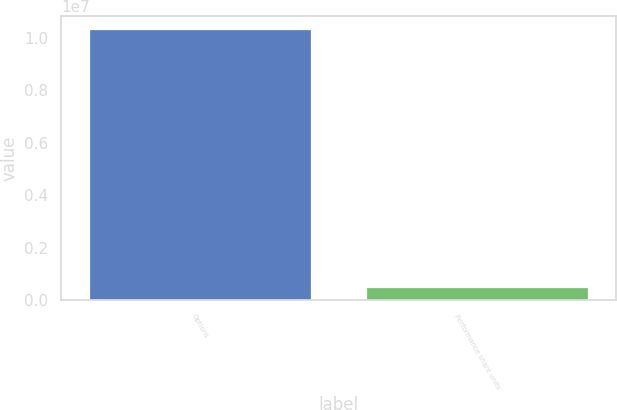Convert chart. <chart><loc_0><loc_0><loc_500><loc_500><bar_chart><fcel>Options<fcel>Performance share units<nl><fcel>1.03128e+07<fcel>496343<nl></chart> 